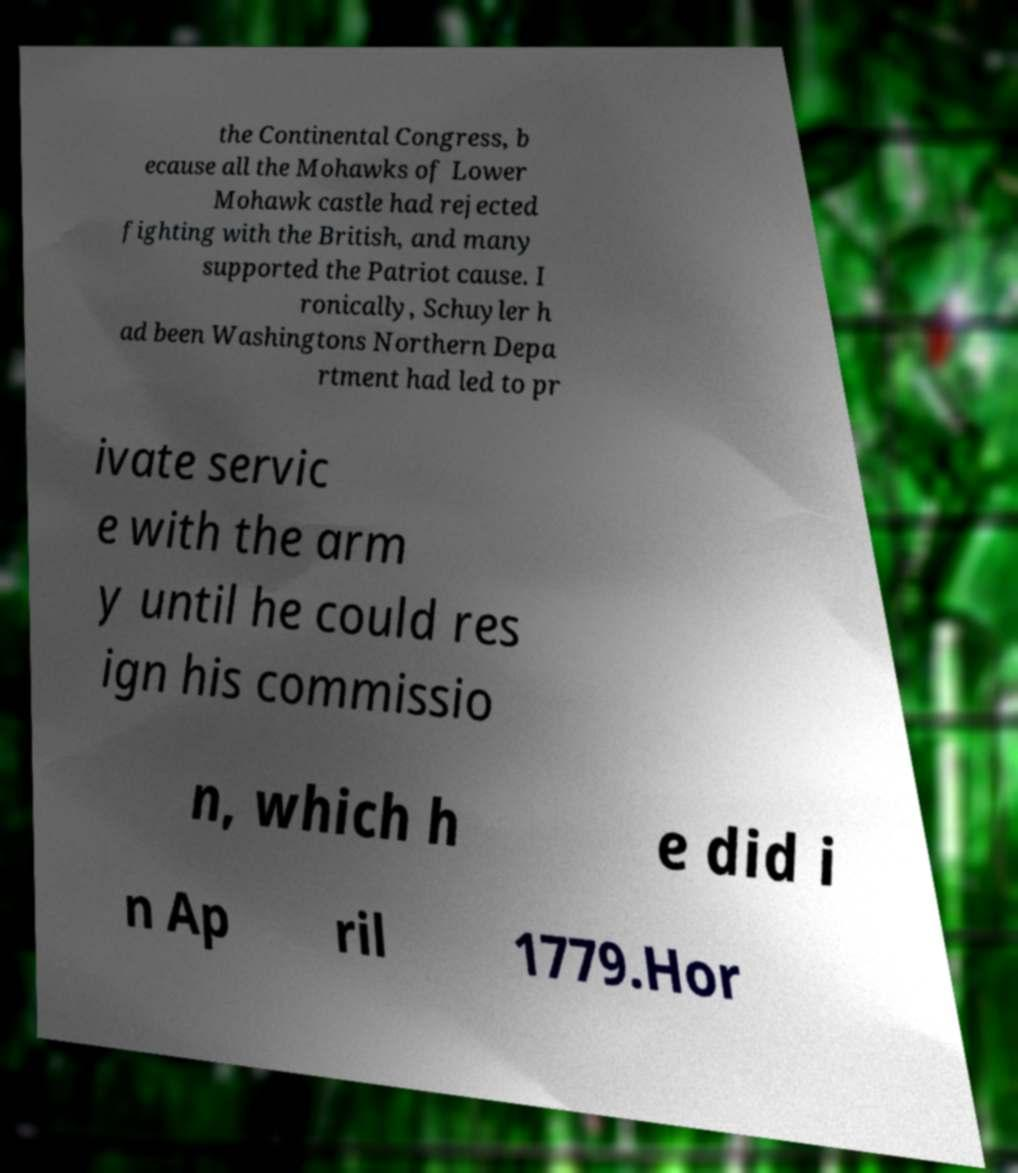Please identify and transcribe the text found in this image. the Continental Congress, b ecause all the Mohawks of Lower Mohawk castle had rejected fighting with the British, and many supported the Patriot cause. I ronically, Schuyler h ad been Washingtons Northern Depa rtment had led to pr ivate servic e with the arm y until he could res ign his commissio n, which h e did i n Ap ril 1779.Hor 